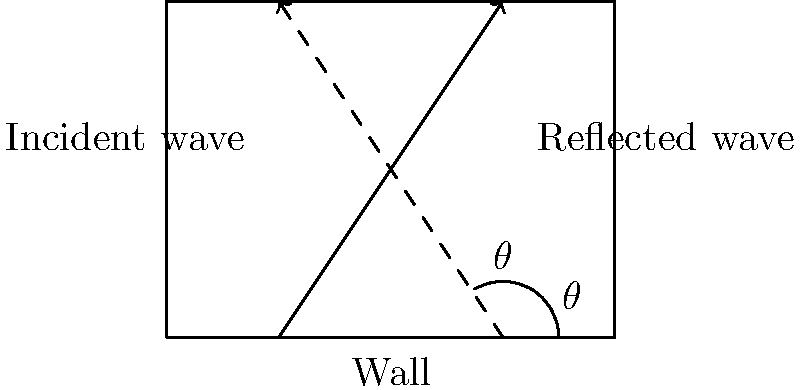In a prison cell, a sound wave hits a wall at an angle of incidence $\theta = 30°$. What is the angle of reflection, and how does this phenomenon relate to the law of reflection in acoustics? To solve this problem, we need to understand and apply the law of reflection in acoustics:

1. The law of reflection states that the angle of incidence is equal to the angle of reflection.

2. In this case, we are given that the angle of incidence $\theta = 30°$.

3. According to the law of reflection, the angle of reflection will also be $30°$.

4. This principle is crucial in understanding how sound waves behave in enclosed spaces like prison cells.

5. The reflection of sound waves off walls contributes to the overall acoustics of the space, affecting how sound is perceived within the cell.

6. In the context of creating auditory representations of the prison experience, understanding this principle can help in accurately simulating the acoustic environment of a prison cell.

7. The reflected sound waves can create echoes, reverberations, and other acoustic effects that contribute to the unique soundscape of a confined space.
Answer: $30°$ 